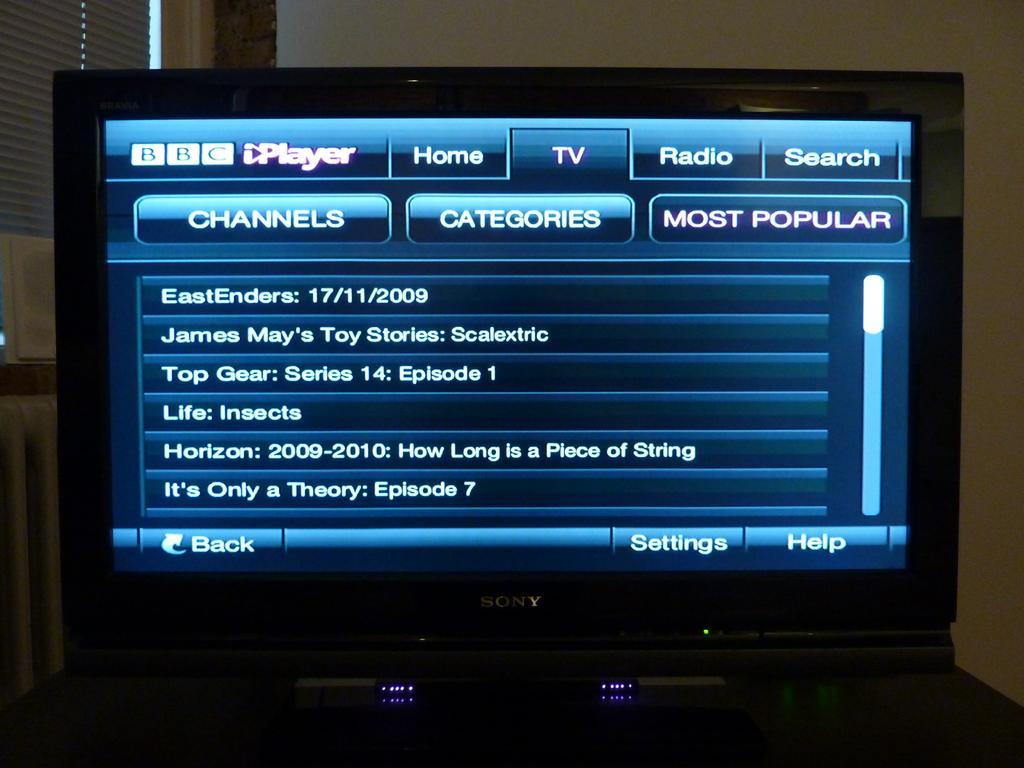Please provide a concise description of this image. We can see screen,in this screen we can see some information. In the background we can see wall. 